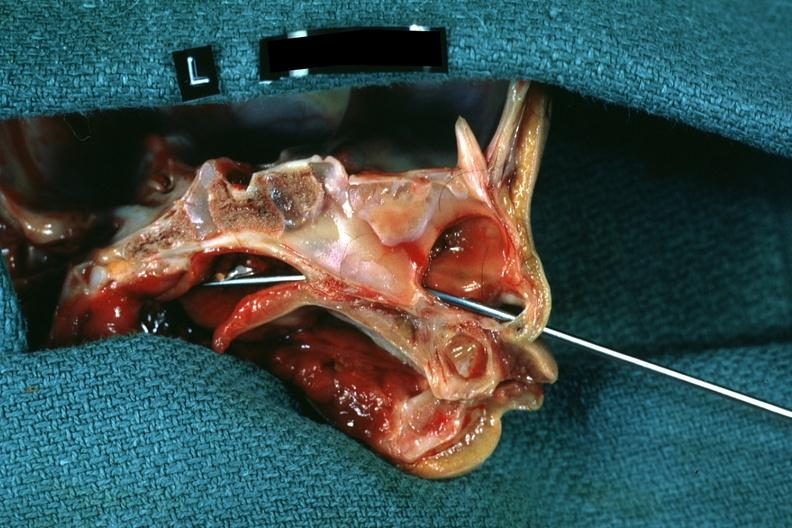what left side showing patency right side was not patent?
Answer the question using a single word or phrase. Hemisection of nose 